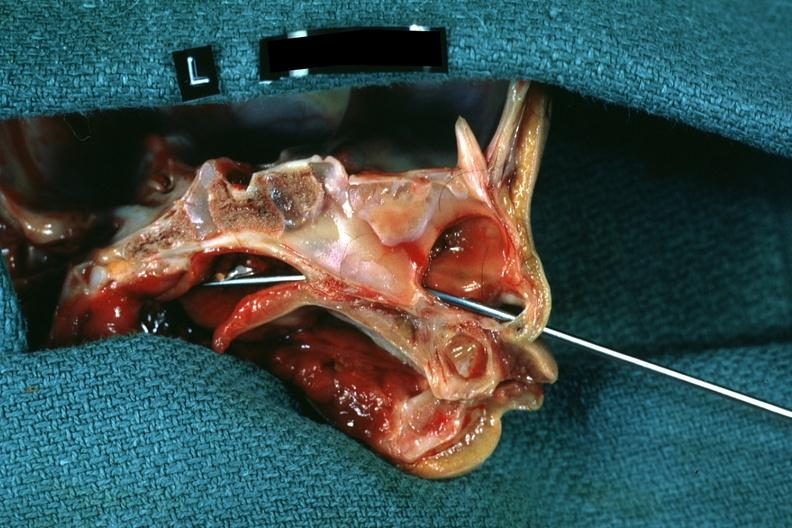what left side showing patency right side was not patent?
Answer the question using a single word or phrase. Hemisection of nose 